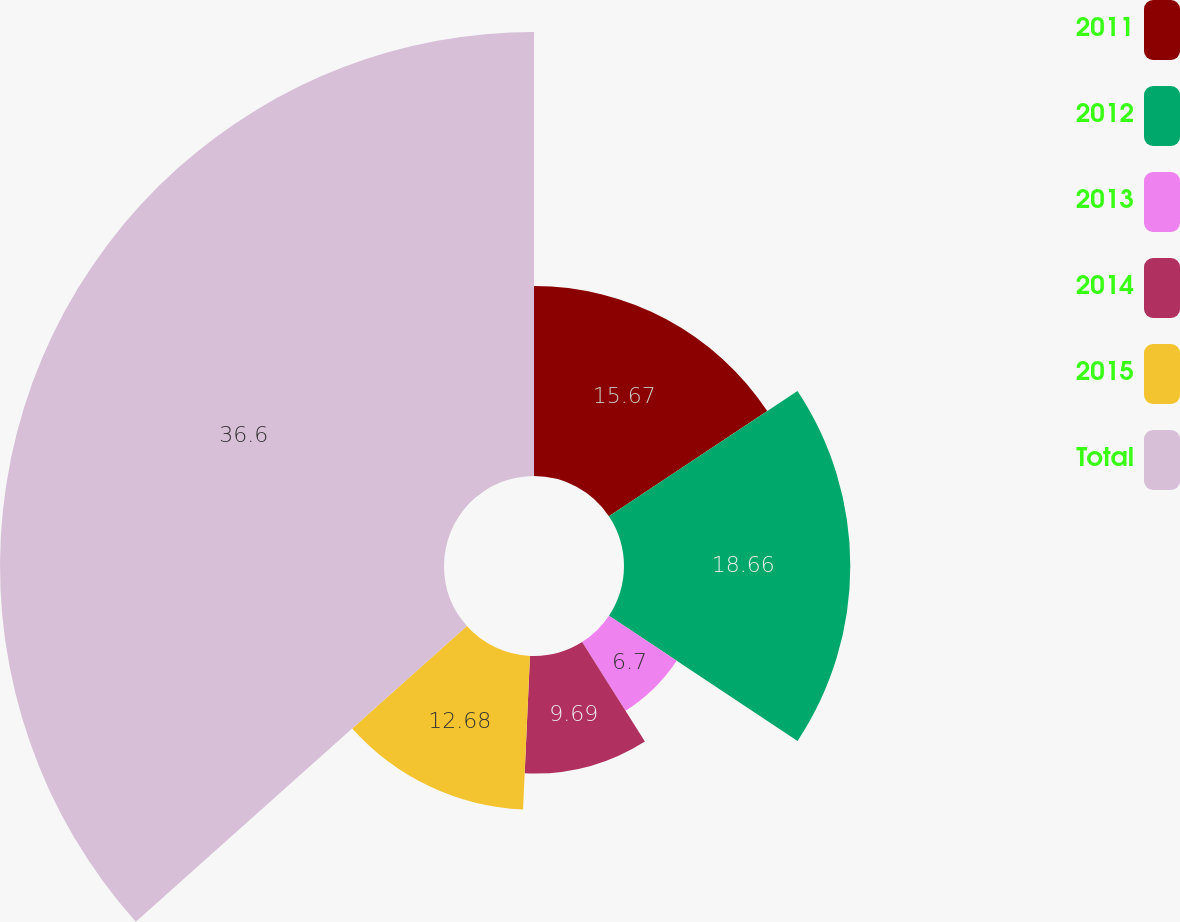Convert chart to OTSL. <chart><loc_0><loc_0><loc_500><loc_500><pie_chart><fcel>2011<fcel>2012<fcel>2013<fcel>2014<fcel>2015<fcel>Total<nl><fcel>15.67%<fcel>18.66%<fcel>6.7%<fcel>9.69%<fcel>12.68%<fcel>36.61%<nl></chart> 